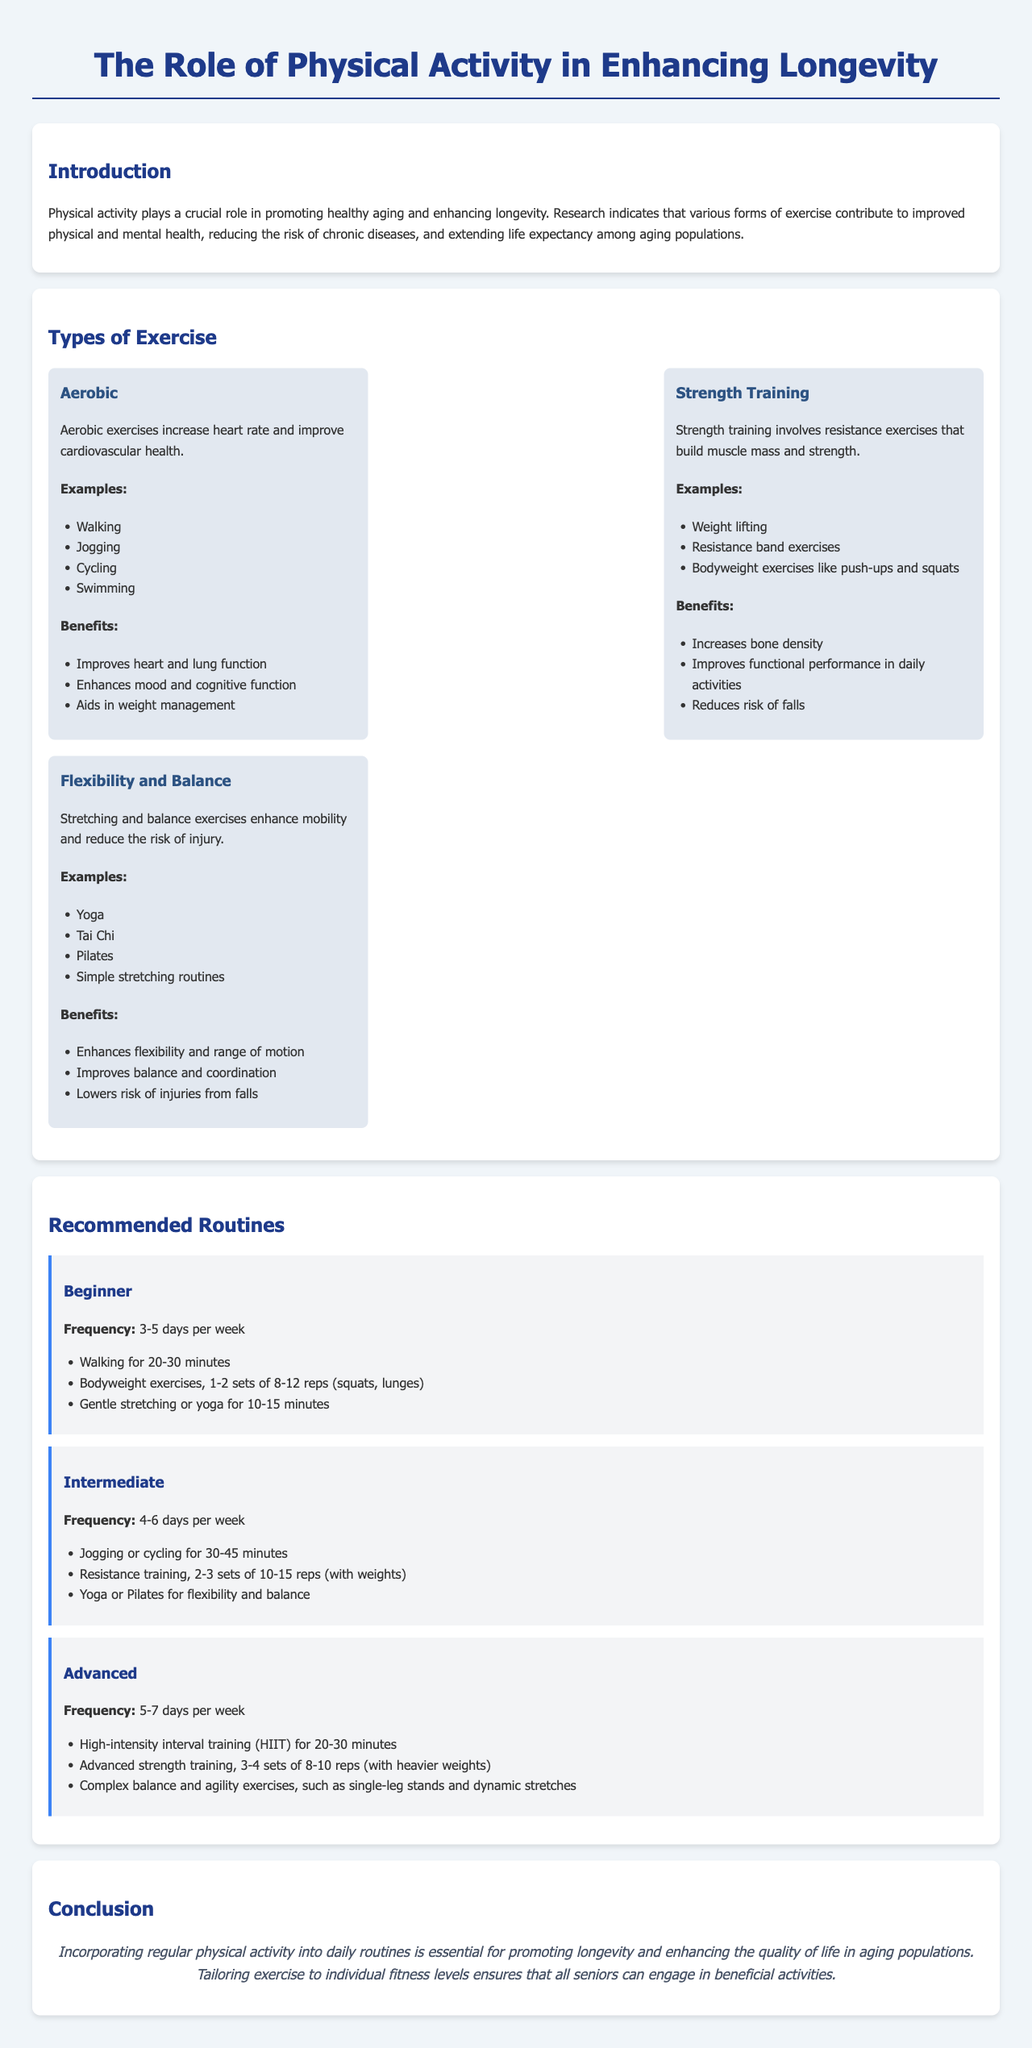What is the main role of physical activity according to the document? The document states that physical activity plays a crucial role in promoting healthy aging and enhancing longevity.
Answer: Enhancing longevity How many days per week is the recommended frequency for beginner routines? The report suggests a frequency of 3-5 days per week for beginner routines.
Answer: 3-5 days What type of exercise is characterized by increasing heart rate? The document mentions that aerobic exercises increase heart rate.
Answer: Aerobic Name one strength training exercise mentioned in the report. The report lists weight lifting as an example of strength training.
Answer: Weight lifting What is a benefit of flexibility and balance exercises? The report states that one benefit is improving balance and coordination.
Answer: Improves balance and coordination What is the recommended duration for walking in the beginner routine? The document recommends walking for 20-30 minutes in the beginner routine.
Answer: 20-30 minutes How often should advanced individuals engage in high-intensity interval training (HIIT) according to the report? The report recommends 5-7 days per week for advanced individuals practicing HIIT.
Answer: 5-7 days What type of exercise can aid in weight management? The report indicates that aerobic exercises can aid in weight management.
Answer: Aerobic exercises What is the concluding statement about incorporating physical activity? The conclusion emphasizes that incorporating regular physical activity into daily routines is essential.
Answer: Essential for promoting longevity 